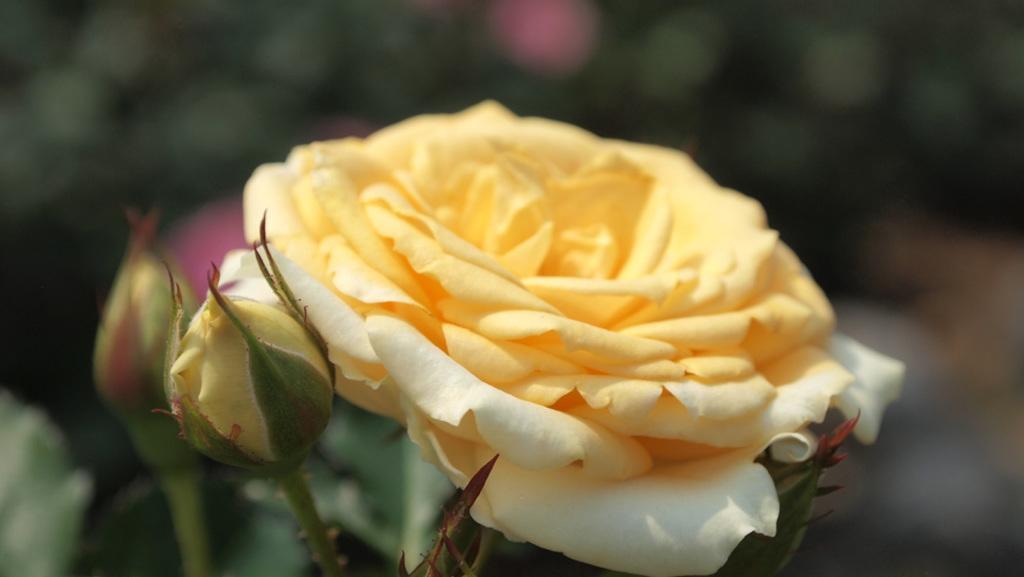Can you describe this image briefly? In this image there are plants having flowers and buds. Background is blurry. 